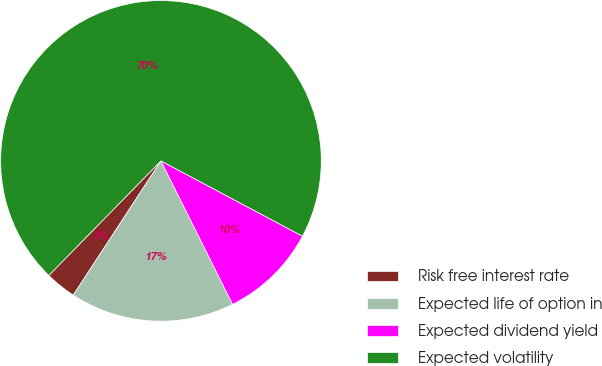<chart> <loc_0><loc_0><loc_500><loc_500><pie_chart><fcel>Risk free interest rate<fcel>Expected life of option in<fcel>Expected dividend yield<fcel>Expected volatility<nl><fcel>3.12%<fcel>16.58%<fcel>9.85%<fcel>70.45%<nl></chart> 